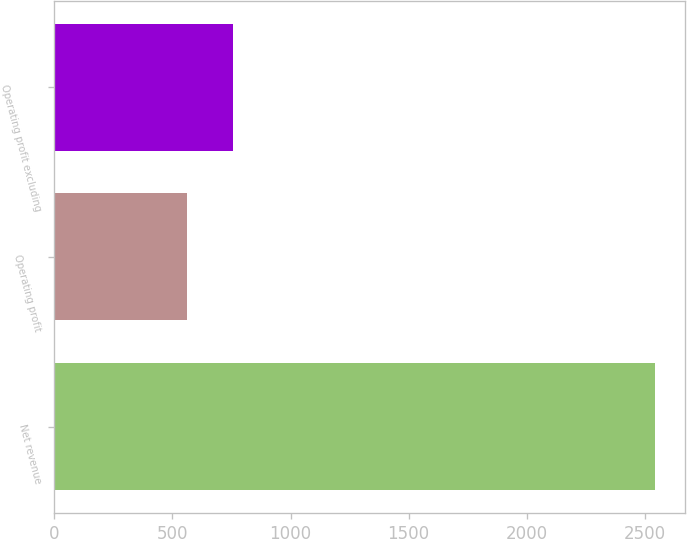Convert chart. <chart><loc_0><loc_0><loc_500><loc_500><bar_chart><fcel>Net revenue<fcel>Operating profit<fcel>Operating profit excluding<nl><fcel>2543<fcel>560<fcel>758.3<nl></chart> 